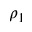<formula> <loc_0><loc_0><loc_500><loc_500>\rho _ { 1 }</formula> 